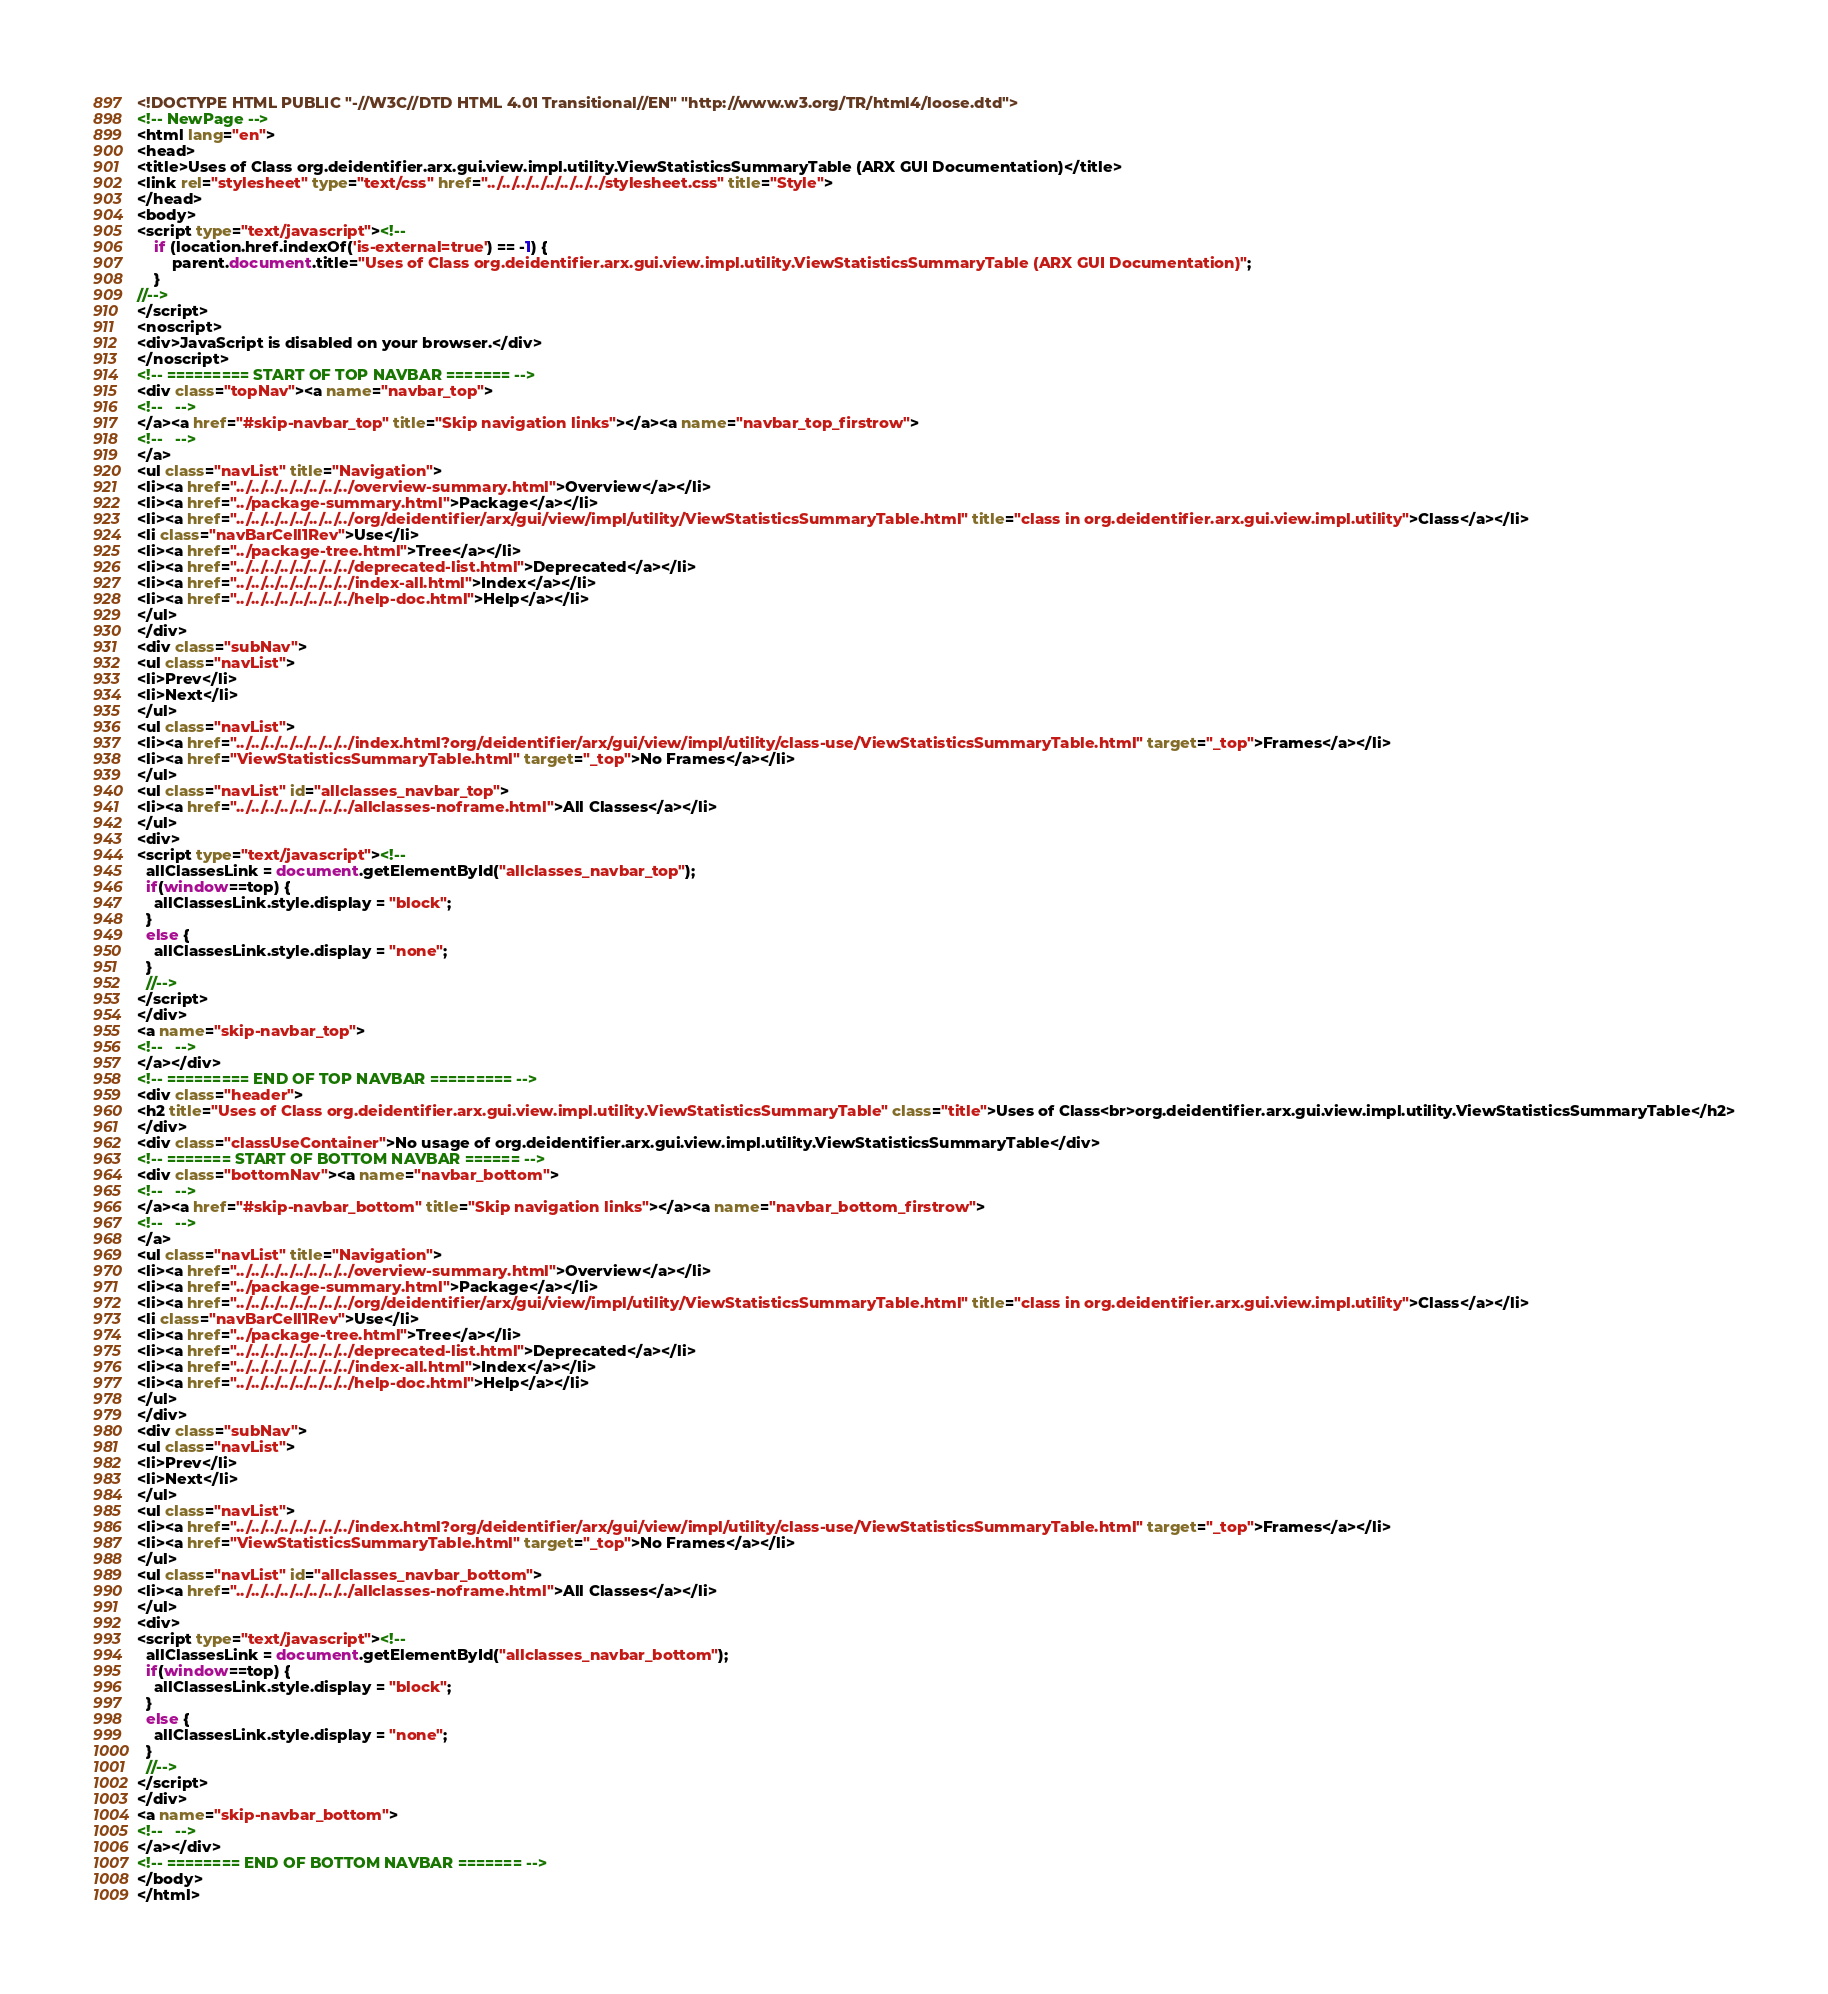Convert code to text. <code><loc_0><loc_0><loc_500><loc_500><_HTML_><!DOCTYPE HTML PUBLIC "-//W3C//DTD HTML 4.01 Transitional//EN" "http://www.w3.org/TR/html4/loose.dtd">
<!-- NewPage -->
<html lang="en">
<head>
<title>Uses of Class org.deidentifier.arx.gui.view.impl.utility.ViewStatisticsSummaryTable (ARX GUI Documentation)</title>
<link rel="stylesheet" type="text/css" href="../../../../../../../../stylesheet.css" title="Style">
</head>
<body>
<script type="text/javascript"><!--
    if (location.href.indexOf('is-external=true') == -1) {
        parent.document.title="Uses of Class org.deidentifier.arx.gui.view.impl.utility.ViewStatisticsSummaryTable (ARX GUI Documentation)";
    }
//-->
</script>
<noscript>
<div>JavaScript is disabled on your browser.</div>
</noscript>
<!-- ========= START OF TOP NAVBAR ======= -->
<div class="topNav"><a name="navbar_top">
<!--   -->
</a><a href="#skip-navbar_top" title="Skip navigation links"></a><a name="navbar_top_firstrow">
<!--   -->
</a>
<ul class="navList" title="Navigation">
<li><a href="../../../../../../../../overview-summary.html">Overview</a></li>
<li><a href="../package-summary.html">Package</a></li>
<li><a href="../../../../../../../../org/deidentifier/arx/gui/view/impl/utility/ViewStatisticsSummaryTable.html" title="class in org.deidentifier.arx.gui.view.impl.utility">Class</a></li>
<li class="navBarCell1Rev">Use</li>
<li><a href="../package-tree.html">Tree</a></li>
<li><a href="../../../../../../../../deprecated-list.html">Deprecated</a></li>
<li><a href="../../../../../../../../index-all.html">Index</a></li>
<li><a href="../../../../../../../../help-doc.html">Help</a></li>
</ul>
</div>
<div class="subNav">
<ul class="navList">
<li>Prev</li>
<li>Next</li>
</ul>
<ul class="navList">
<li><a href="../../../../../../../../index.html?org/deidentifier/arx/gui/view/impl/utility/class-use/ViewStatisticsSummaryTable.html" target="_top">Frames</a></li>
<li><a href="ViewStatisticsSummaryTable.html" target="_top">No Frames</a></li>
</ul>
<ul class="navList" id="allclasses_navbar_top">
<li><a href="../../../../../../../../allclasses-noframe.html">All Classes</a></li>
</ul>
<div>
<script type="text/javascript"><!--
  allClassesLink = document.getElementById("allclasses_navbar_top");
  if(window==top) {
    allClassesLink.style.display = "block";
  }
  else {
    allClassesLink.style.display = "none";
  }
  //-->
</script>
</div>
<a name="skip-navbar_top">
<!--   -->
</a></div>
<!-- ========= END OF TOP NAVBAR ========= -->
<div class="header">
<h2 title="Uses of Class org.deidentifier.arx.gui.view.impl.utility.ViewStatisticsSummaryTable" class="title">Uses of Class<br>org.deidentifier.arx.gui.view.impl.utility.ViewStatisticsSummaryTable</h2>
</div>
<div class="classUseContainer">No usage of org.deidentifier.arx.gui.view.impl.utility.ViewStatisticsSummaryTable</div>
<!-- ======= START OF BOTTOM NAVBAR ====== -->
<div class="bottomNav"><a name="navbar_bottom">
<!--   -->
</a><a href="#skip-navbar_bottom" title="Skip navigation links"></a><a name="navbar_bottom_firstrow">
<!--   -->
</a>
<ul class="navList" title="Navigation">
<li><a href="../../../../../../../../overview-summary.html">Overview</a></li>
<li><a href="../package-summary.html">Package</a></li>
<li><a href="../../../../../../../../org/deidentifier/arx/gui/view/impl/utility/ViewStatisticsSummaryTable.html" title="class in org.deidentifier.arx.gui.view.impl.utility">Class</a></li>
<li class="navBarCell1Rev">Use</li>
<li><a href="../package-tree.html">Tree</a></li>
<li><a href="../../../../../../../../deprecated-list.html">Deprecated</a></li>
<li><a href="../../../../../../../../index-all.html">Index</a></li>
<li><a href="../../../../../../../../help-doc.html">Help</a></li>
</ul>
</div>
<div class="subNav">
<ul class="navList">
<li>Prev</li>
<li>Next</li>
</ul>
<ul class="navList">
<li><a href="../../../../../../../../index.html?org/deidentifier/arx/gui/view/impl/utility/class-use/ViewStatisticsSummaryTable.html" target="_top">Frames</a></li>
<li><a href="ViewStatisticsSummaryTable.html" target="_top">No Frames</a></li>
</ul>
<ul class="navList" id="allclasses_navbar_bottom">
<li><a href="../../../../../../../../allclasses-noframe.html">All Classes</a></li>
</ul>
<div>
<script type="text/javascript"><!--
  allClassesLink = document.getElementById("allclasses_navbar_bottom");
  if(window==top) {
    allClassesLink.style.display = "block";
  }
  else {
    allClassesLink.style.display = "none";
  }
  //-->
</script>
</div>
<a name="skip-navbar_bottom">
<!--   -->
</a></div>
<!-- ======== END OF BOTTOM NAVBAR ======= -->
</body>
</html>
</code> 